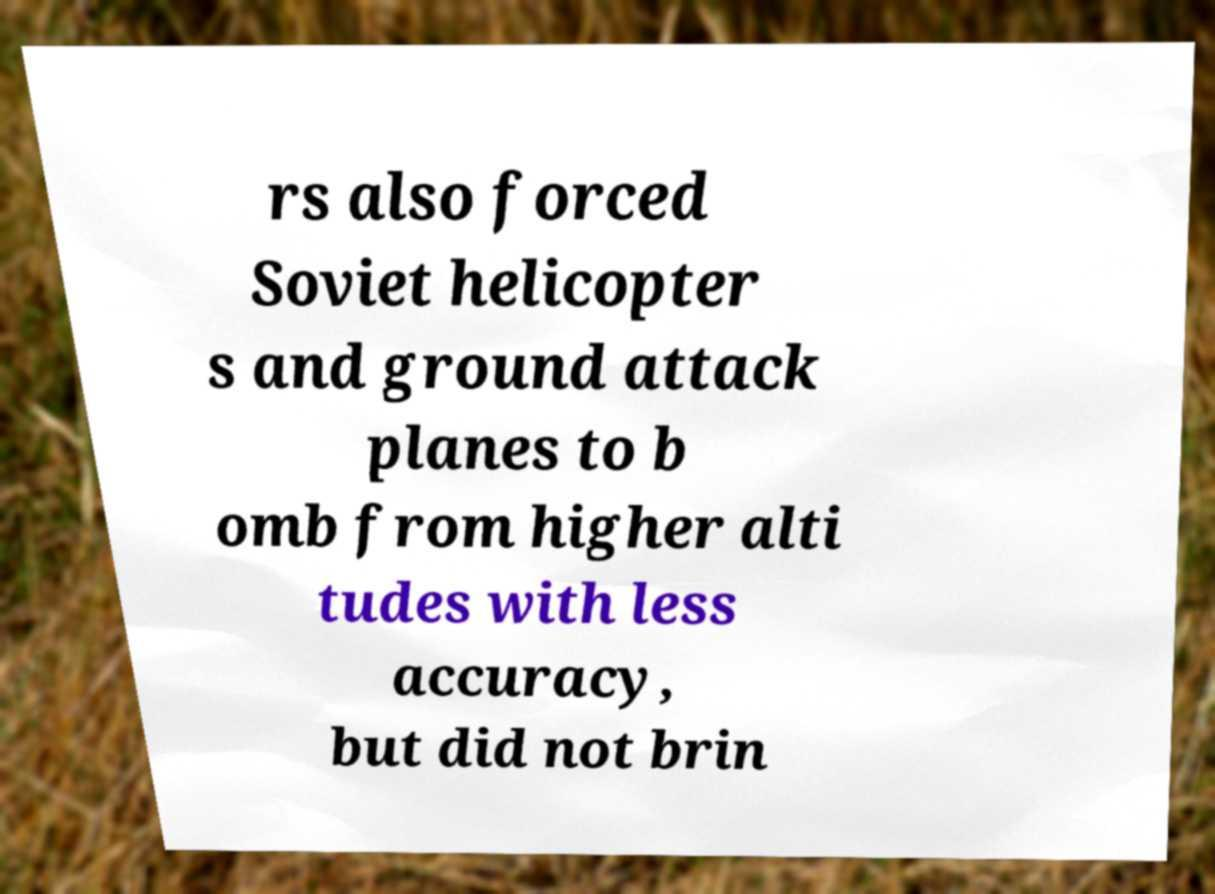Please identify and transcribe the text found in this image. rs also forced Soviet helicopter s and ground attack planes to b omb from higher alti tudes with less accuracy, but did not brin 